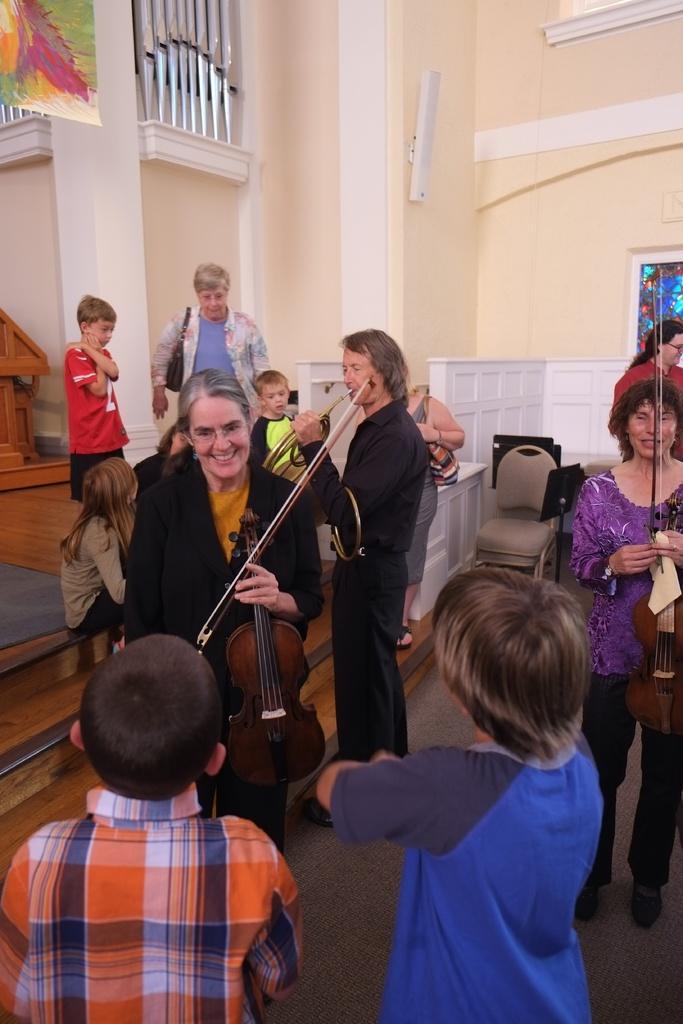Can you describe this image briefly? in the picture there is a room,in which many people are standing and holding musical items and playing,there are small children in that room. 